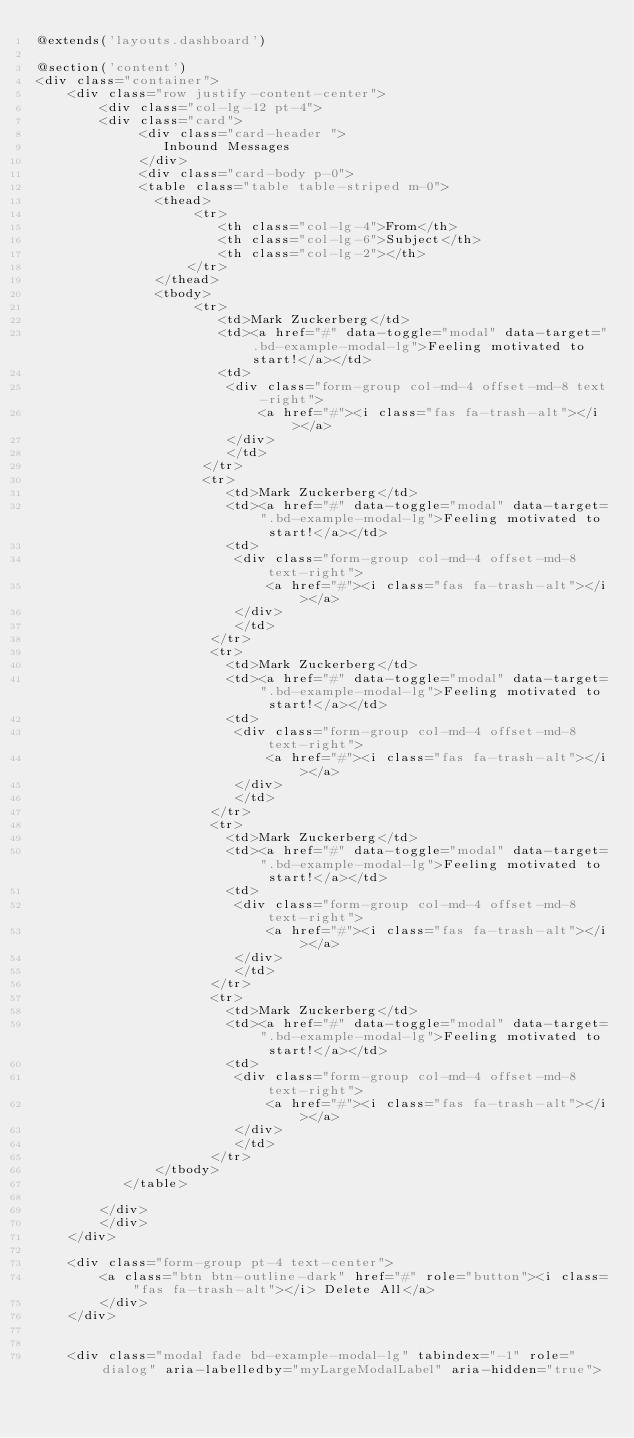<code> <loc_0><loc_0><loc_500><loc_500><_PHP_>@extends('layouts.dashboard')

@section('content')
<div class="container">
    <div class="row justify-content-center">
        <div class="col-lg-12 pt-4">
        <div class="card">
             <div class="card-header ">
                Inbound Messages 
             </div>
             <div class="card-body p-0">
             <table class="table table-striped m-0">
               <thead>
                    <tr>
                       <th class="col-lg-4">From</th>
                       <th class="col-lg-6">Subject</th>
                       <th class="col-lg-2"></th>
                   </tr>
               </thead>
               <tbody>
                    <tr>
                       <td>Mark Zuckerberg</td>
                       <td><a href="#" data-toggle="modal" data-target=".bd-example-modal-lg">Feeling motivated to start!</a></td>
                       <td>
                        <div class="form-group col-md-4 offset-md-8 text-right">
                            <a href="#"><i class="fas fa-trash-alt"></i></a>
                        </div>     
                        </td> 
                     </tr>
                     <tr>
                        <td>Mark Zuckerberg</td>
                        <td><a href="#" data-toggle="modal" data-target=".bd-example-modal-lg">Feeling motivated to start!</a></td>
                        <td>
                         <div class="form-group col-md-4 offset-md-8 text-right">
                             <a href="#"><i class="fas fa-trash-alt"></i></a>
                         </div>     
                         </td> 
                      </tr>
                      <tr>
                        <td>Mark Zuckerberg</td>
                        <td><a href="#" data-toggle="modal" data-target=".bd-example-modal-lg">Feeling motivated to start!</a></td>
                        <td>
                         <div class="form-group col-md-4 offset-md-8 text-right">
                             <a href="#"><i class="fas fa-trash-alt"></i></a>
                         </div>     
                         </td> 
                      </tr>
                      <tr>
                        <td>Mark Zuckerberg</td>
                        <td><a href="#" data-toggle="modal" data-target=".bd-example-modal-lg">Feeling motivated to start!</a></td>
                        <td>
                         <div class="form-group col-md-4 offset-md-8 text-right">
                             <a href="#"><i class="fas fa-trash-alt"></i></a>
                         </div>     
                         </td> 
                      </tr>
                      <tr>
                        <td>Mark Zuckerberg</td>
                        <td><a href="#" data-toggle="modal" data-target=".bd-example-modal-lg">Feeling motivated to start!</a></td>
                        <td>
                         <div class="form-group col-md-4 offset-md-8 text-right">
                             <a href="#"><i class="fas fa-trash-alt"></i></a>
                         </div>     
                         </td> 
                      </tr>
               </tbody>
           </table>

        </div>
        </div>
    </div>

    <div class="form-group pt-4 text-center">
        <a class="btn btn-outline-dark" href="#" role="button"><i class="fas fa-trash-alt"></i> Delete All</a>
        </div>
    </div>


    <div class="modal fade bd-example-modal-lg" tabindex="-1" role="dialog" aria-labelledby="myLargeModalLabel" aria-hidden="true"></code> 